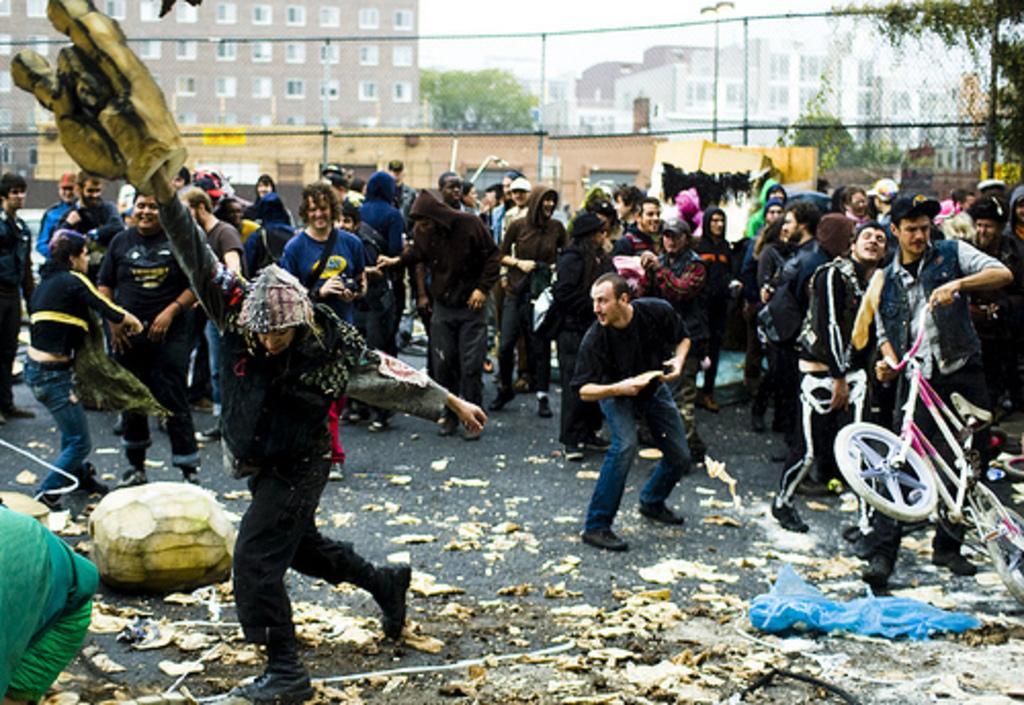Please provide a concise description of this image. In this picture we can see there are some people standing and a person is holding a bicycle and another person is holding an object. Behind the people there is a fence, trees, buildings and a sky. On the road there are some items. 